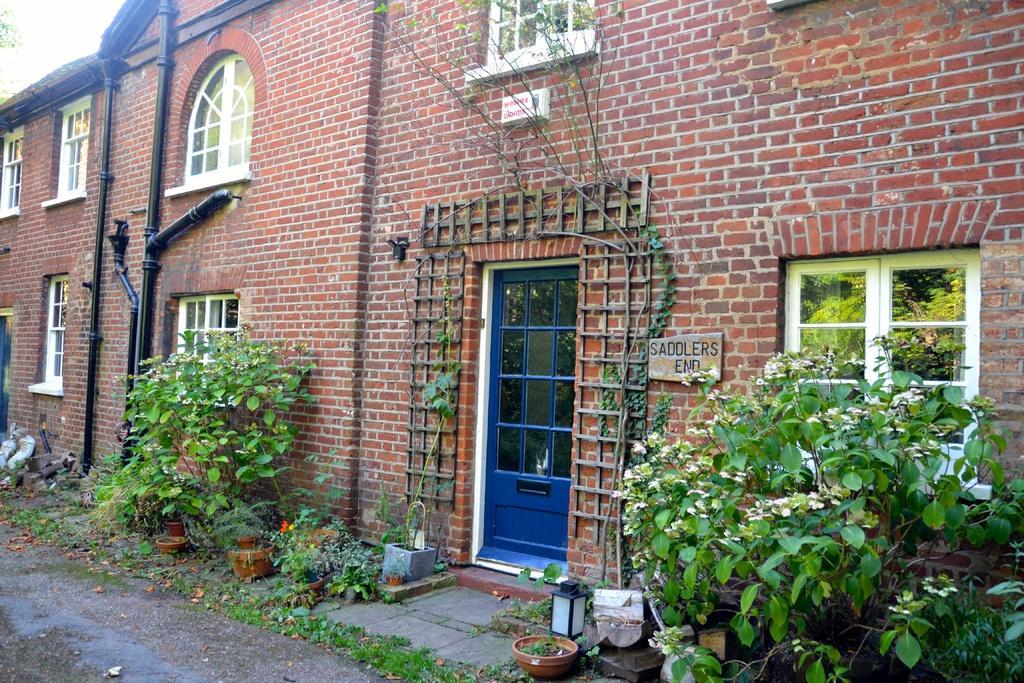What type of structure is in the image? There is a brick building in the image. What architectural feature can be observed on the building? The building has many windows. What type of vegetation is present in front of the building? Small plants are present in front of the building. Can you see a robin perched on a twig in the image? There is no robin or twig present in the image. What shape is the circle that surrounds the building in the image? There is no circle surrounding the building in the image. 